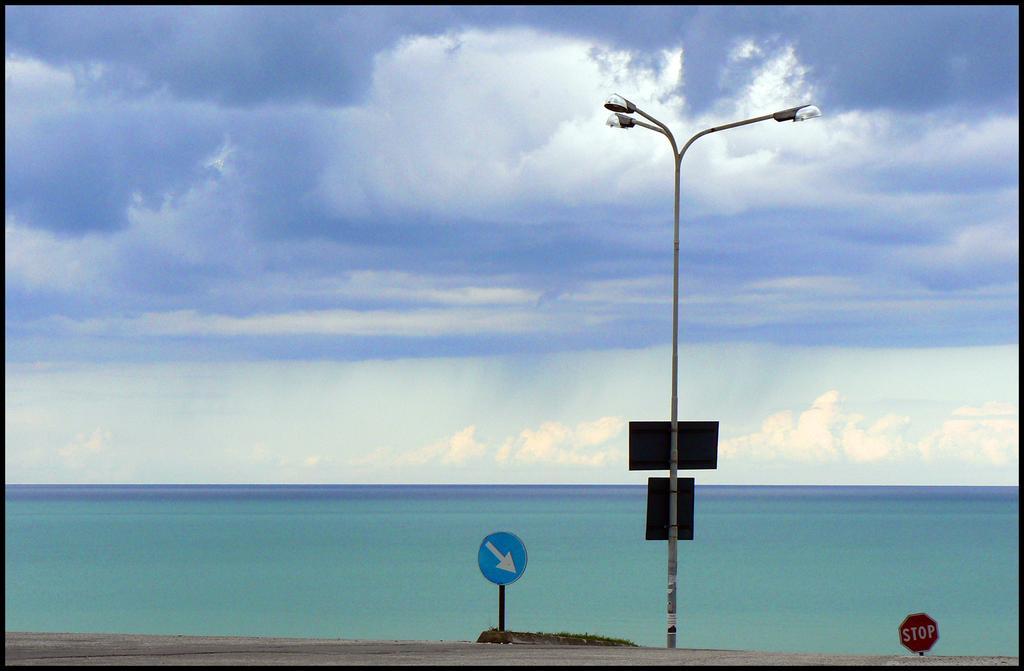How would you summarize this image in a sentence or two? In the picture I can see street light and there are two sign boards on either sides of it and there is water in the background and the sky is cloudy. 